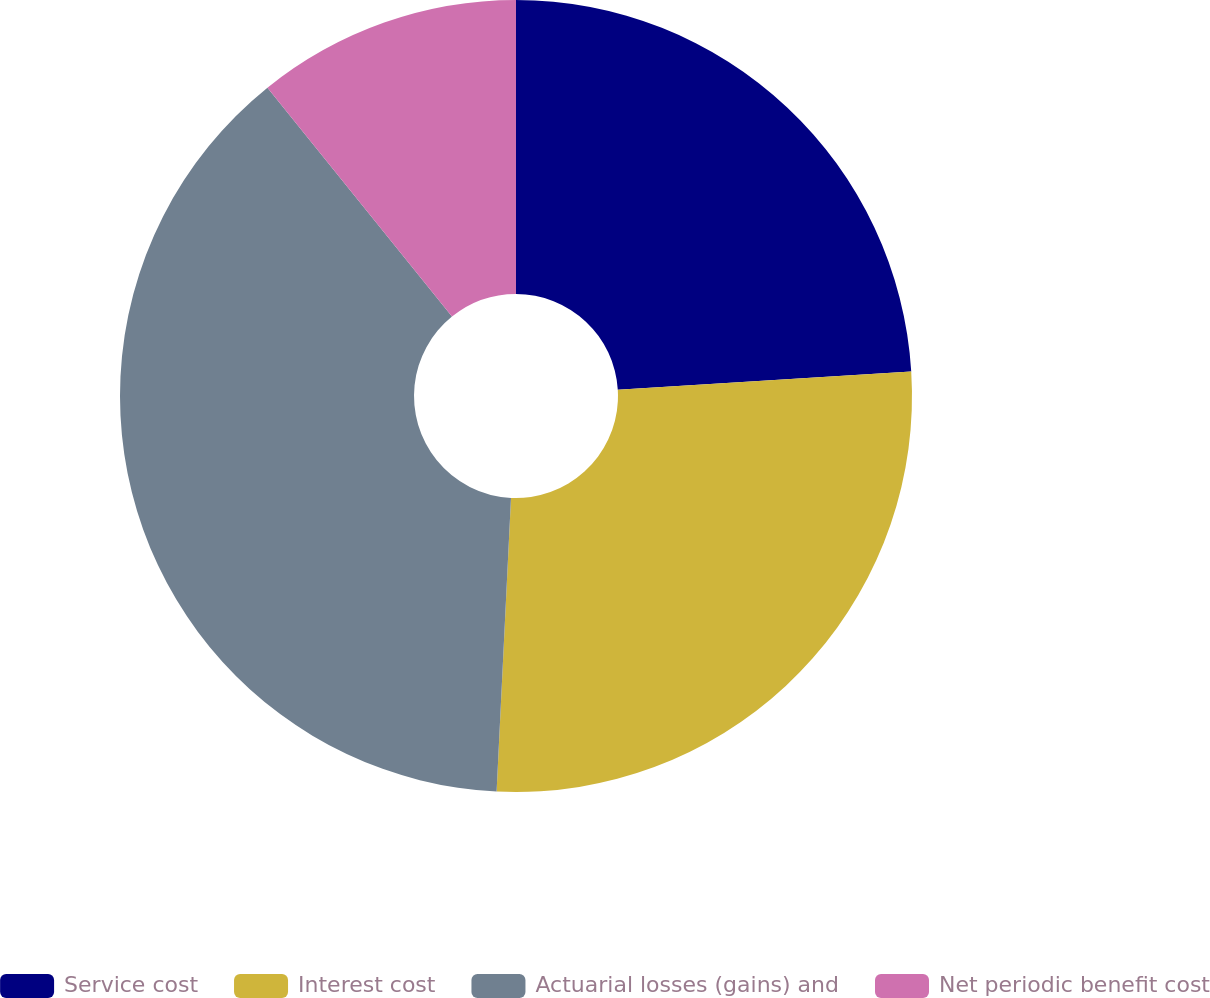<chart> <loc_0><loc_0><loc_500><loc_500><pie_chart><fcel>Service cost<fcel>Interest cost<fcel>Actuarial losses (gains) and<fcel>Net periodic benefit cost<nl><fcel>24.01%<fcel>26.77%<fcel>38.42%<fcel>10.8%<nl></chart> 